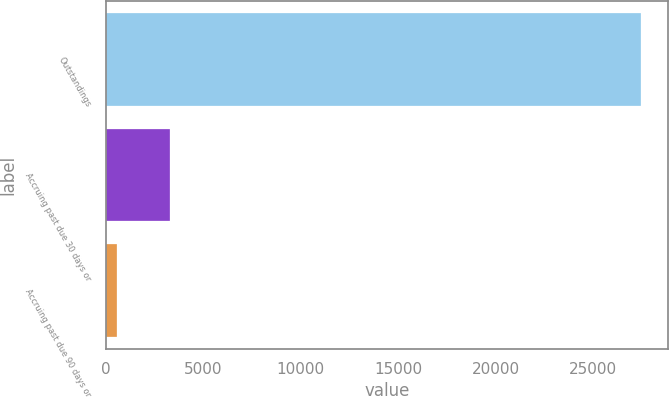<chart> <loc_0><loc_0><loc_500><loc_500><bar_chart><fcel>Outstandings<fcel>Accruing past due 30 days or<fcel>Accruing past due 90 days or<nl><fcel>27465<fcel>3285.6<fcel>599<nl></chart> 